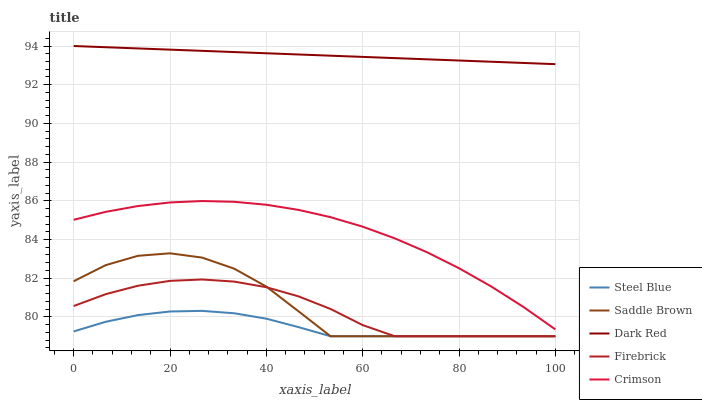Does Steel Blue have the minimum area under the curve?
Answer yes or no. Yes. Does Dark Red have the maximum area under the curve?
Answer yes or no. Yes. Does Firebrick have the minimum area under the curve?
Answer yes or no. No. Does Firebrick have the maximum area under the curve?
Answer yes or no. No. Is Dark Red the smoothest?
Answer yes or no. Yes. Is Saddle Brown the roughest?
Answer yes or no. Yes. Is Firebrick the smoothest?
Answer yes or no. No. Is Firebrick the roughest?
Answer yes or no. No. Does Firebrick have the lowest value?
Answer yes or no. Yes. Does Dark Red have the lowest value?
Answer yes or no. No. Does Dark Red have the highest value?
Answer yes or no. Yes. Does Firebrick have the highest value?
Answer yes or no. No. Is Steel Blue less than Crimson?
Answer yes or no. Yes. Is Crimson greater than Steel Blue?
Answer yes or no. Yes. Does Steel Blue intersect Firebrick?
Answer yes or no. Yes. Is Steel Blue less than Firebrick?
Answer yes or no. No. Is Steel Blue greater than Firebrick?
Answer yes or no. No. Does Steel Blue intersect Crimson?
Answer yes or no. No. 